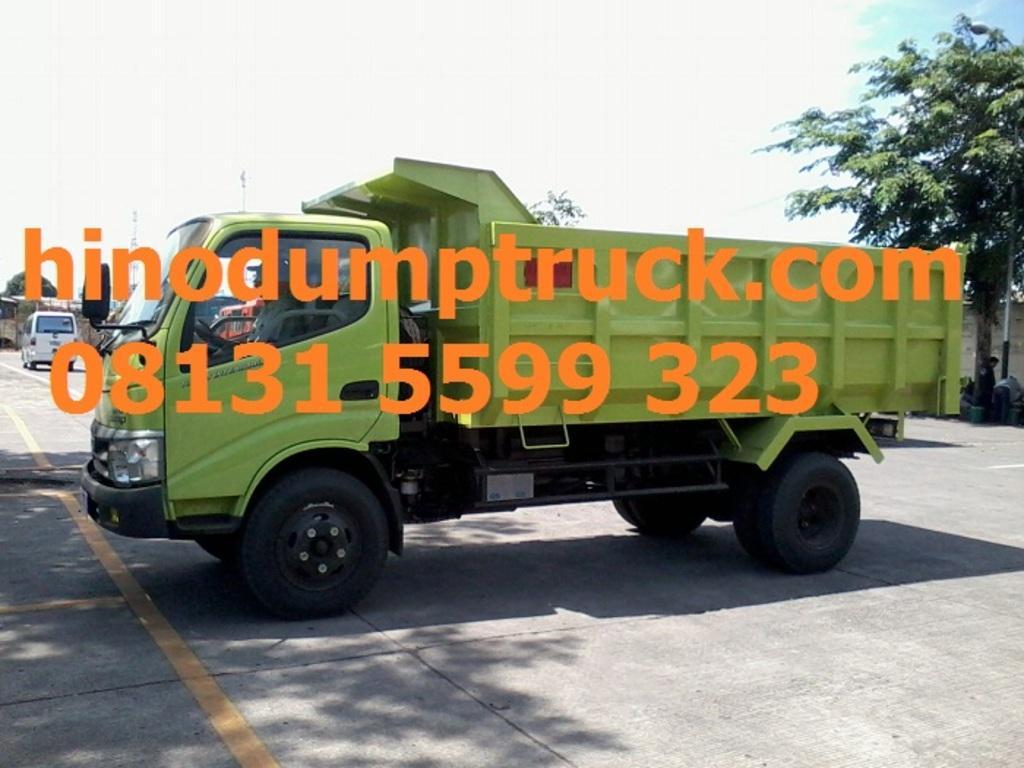Please provide a concise description of this image. In this image we can see vehicles on the road. In the back there are trees and there is sky with clouds. Also we can see text and numbers on the image. 